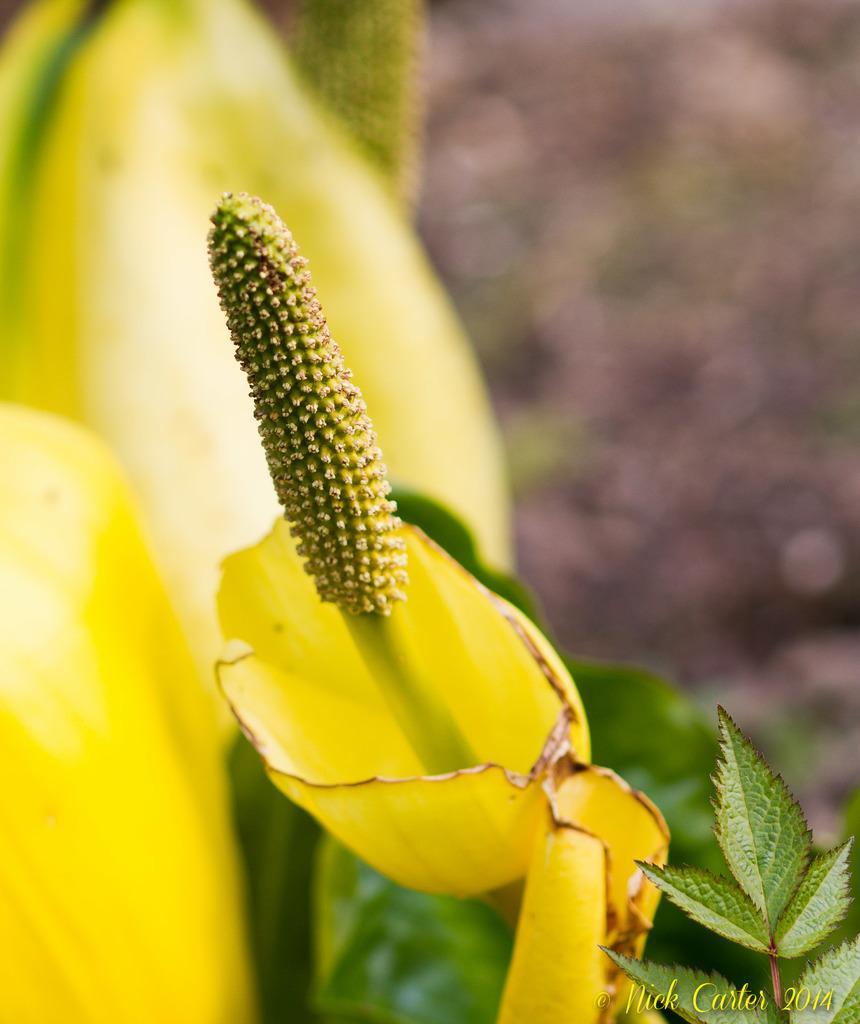How would you summarize this image in a sentence or two? In the center of the image we can see one plant and flowers, which are in yellow color. In the bottom right side of the image, we can see some text. 